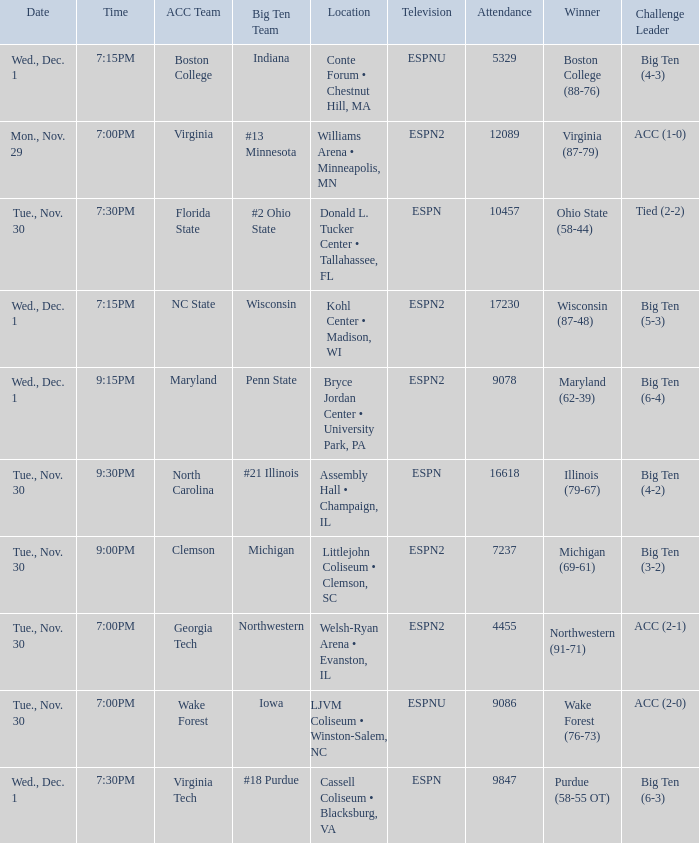Where did the games that had Wisconsin as big ten team take place? Kohl Center • Madison, WI. 